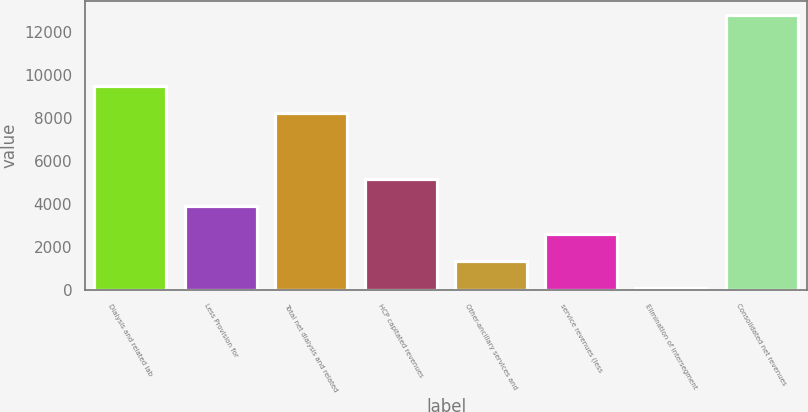<chart> <loc_0><loc_0><loc_500><loc_500><bar_chart><fcel>Dialysis and related lab<fcel>Less Provision for<fcel>Total net dialysis and related<fcel>HCP capitated revenues<fcel>Other-ancillary services and<fcel>service revenues (less<fcel>Elimination of intersegment<fcel>Consolidated net revenues<nl><fcel>9484.8<fcel>3878.4<fcel>8211<fcel>5152.2<fcel>1330.8<fcel>2604.6<fcel>57<fcel>12795<nl></chart> 